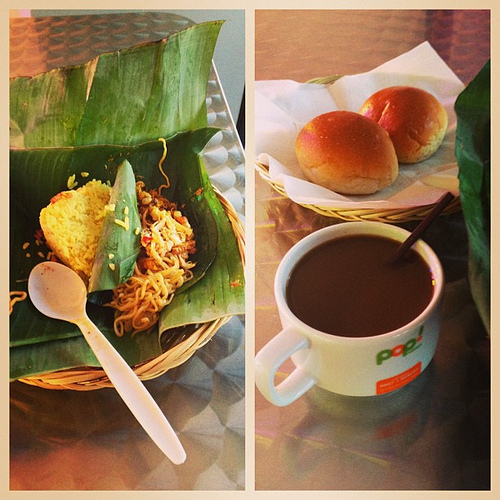What color do you think the buns in the basket are? The buns exhibit a delectable golden hue, suggesting a delicate crust and tender, warm interior. 